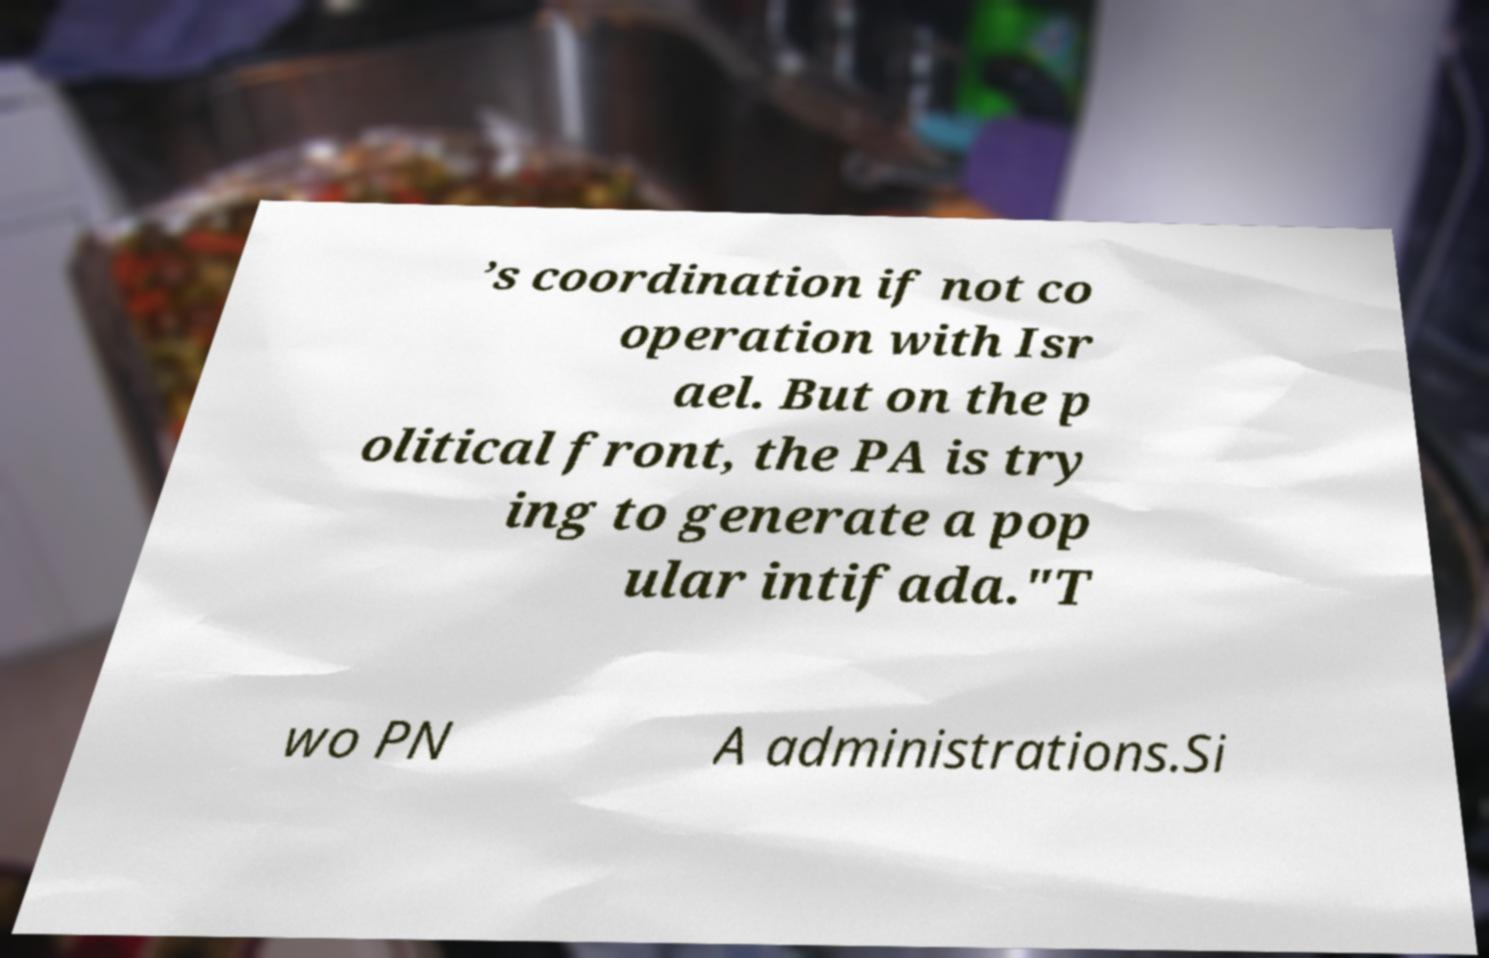Please identify and transcribe the text found in this image. ’s coordination if not co operation with Isr ael. But on the p olitical front, the PA is try ing to generate a pop ular intifada."T wo PN A administrations.Si 